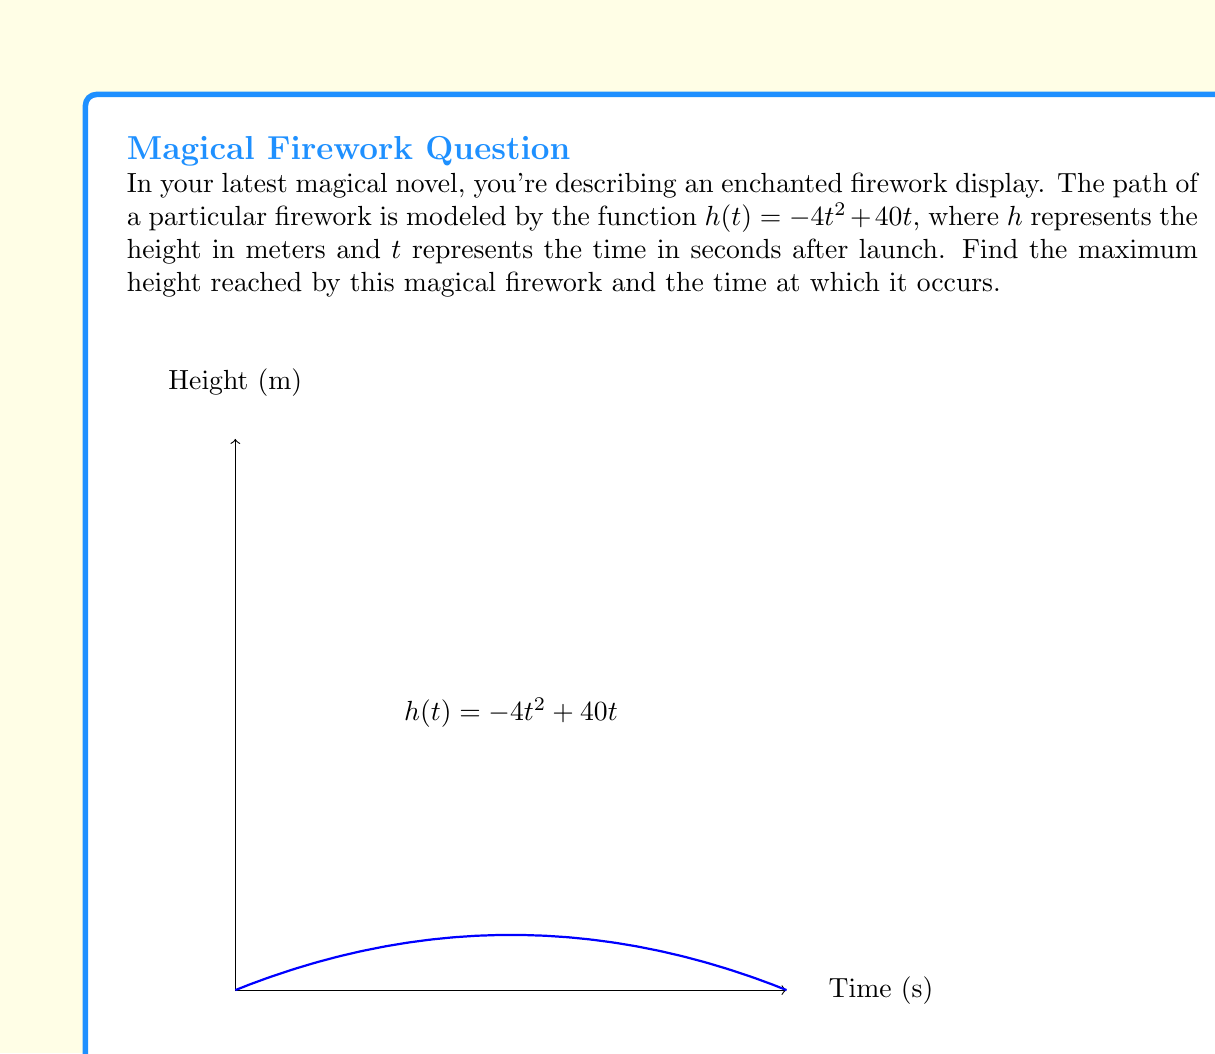Solve this math problem. To find the maximum height of the firework, we need to optimize the function $h(t) = -4t^2 + 40t$. Here's how we can do this using differential calculus:

1) First, we find the derivative of $h(t)$:
   $$h'(t) = -8t + 40$$

2) To find the critical points, we set $h'(t) = 0$ and solve for $t$:
   $$-8t + 40 = 0$$
   $$-8t = -40$$
   $$t = 5$$

3) We can confirm this is a maximum by checking the second derivative:
   $$h''(t) = -8$$
   Since $h''(t)$ is negative for all $t$, the critical point at $t=5$ is indeed a maximum.

4) To find the maximum height, we substitute $t=5$ into the original function:
   $$h(5) = -4(5)^2 + 40(5)$$
   $$= -100 + 200$$
   $$= 100$$

Therefore, the magical firework reaches its maximum height of 100 meters at 5 seconds after launch.
Answer: Maximum height: 100 meters; Time: 5 seconds 